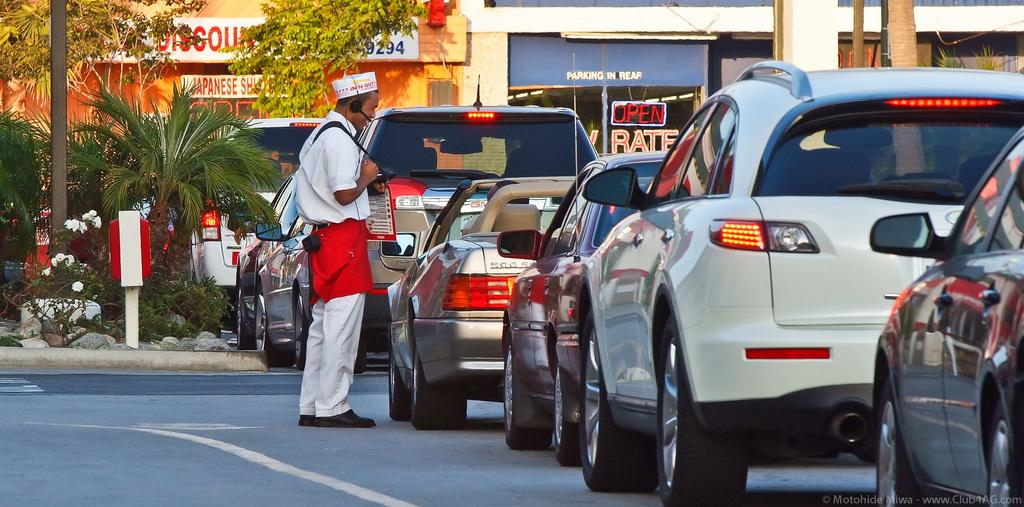What can be seen on the road in the image? There are vehicles on the road in the image. Who is present near the vehicles? There is a person beside the vehicles. What can be seen in the distance in the image? There are buildings, stalls, trees, plants, flowers, and poles in the background of the image. How many eggs are being cooked by the person in the image? There is no person cooking eggs in the image; the person is standing beside the vehicles. What type of cherry is being used as a decoration on the vehicles? There are no cherries present on the vehicles in the image. 